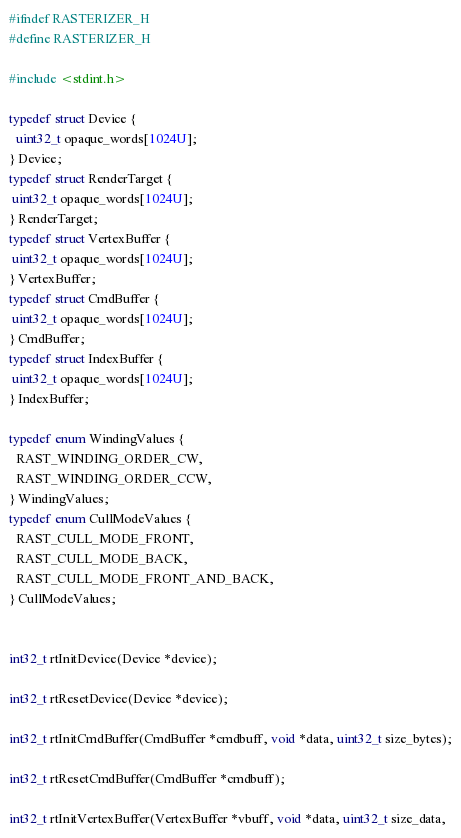<code> <loc_0><loc_0><loc_500><loc_500><_C_>
#ifndef RASTERIZER_H
#define RASTERIZER_H

#include <stdint.h>

typedef struct Device {
  uint32_t opaque_words[1024U];
} Device;
typedef struct RenderTarget {
 uint32_t opaque_words[1024U]; 
} RenderTarget;
typedef struct VertexBuffer {
 uint32_t opaque_words[1024U]; 
} VertexBuffer;
typedef struct CmdBuffer {
 uint32_t opaque_words[1024U]; 
} CmdBuffer;
typedef struct IndexBuffer {
 uint32_t opaque_words[1024U]; 
} IndexBuffer;

typedef enum WindingValues {
  RAST_WINDING_ORDER_CW,
  RAST_WINDING_ORDER_CCW,
} WindingValues;
typedef enum CullModeValues {
  RAST_CULL_MODE_FRONT,
  RAST_CULL_MODE_BACK,
  RAST_CULL_MODE_FRONT_AND_BACK,
} CullModeValues;


int32_t rtInitDevice(Device *device);

int32_t rtResetDevice(Device *device);

int32_t rtInitCmdBuffer(CmdBuffer *cmdbuff, void *data, uint32_t size_bytes);

int32_t rtResetCmdBuffer(CmdBuffer *cmdbuff);

int32_t rtInitVertexBuffer(VertexBuffer *vbuff, void *data, uint32_t size_data,</code> 